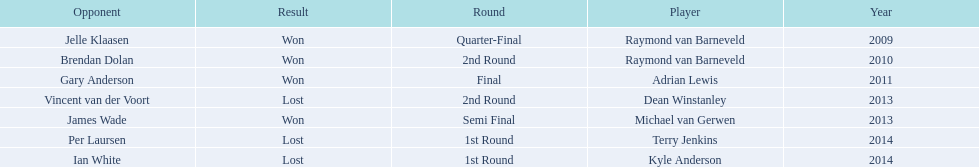What was the names of all the players? Raymond van Barneveld, Raymond van Barneveld, Adrian Lewis, Dean Winstanley, Michael van Gerwen, Terry Jenkins, Kyle Anderson. What years were the championship offered? 2009, 2010, 2011, 2013, 2013, 2014, 2014. Of these, who played in 2011? Adrian Lewis. 